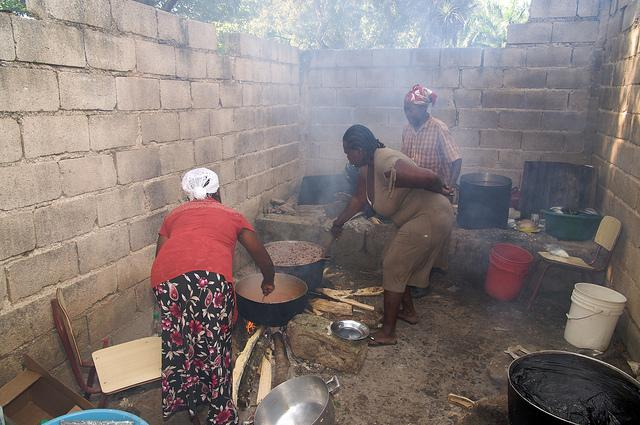What are the women doing over the large containers on the ground? cooking 